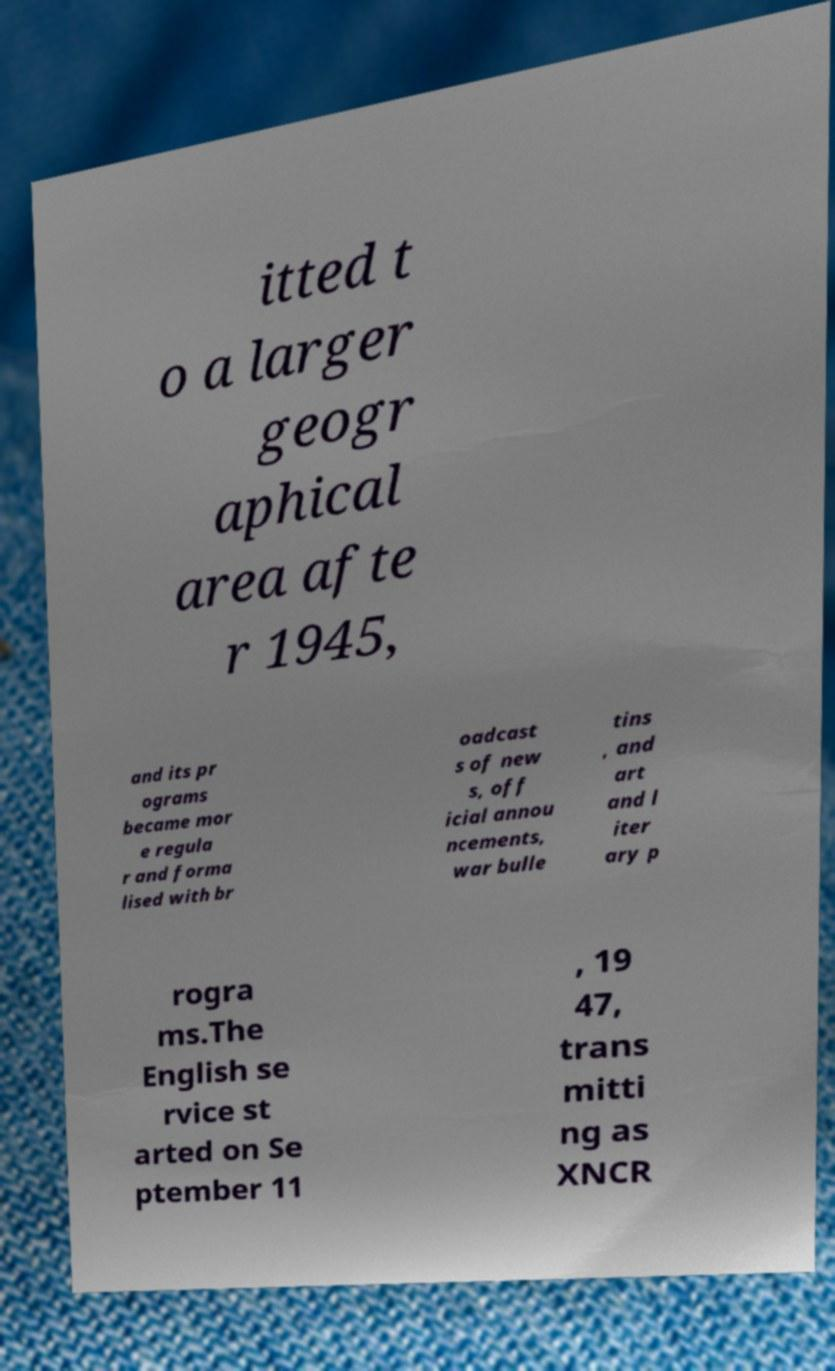Can you read and provide the text displayed in the image?This photo seems to have some interesting text. Can you extract and type it out for me? itted t o a larger geogr aphical area afte r 1945, and its pr ograms became mor e regula r and forma lised with br oadcast s of new s, off icial annou ncements, war bulle tins , and art and l iter ary p rogra ms.The English se rvice st arted on Se ptember 11 , 19 47, trans mitti ng as XNCR 